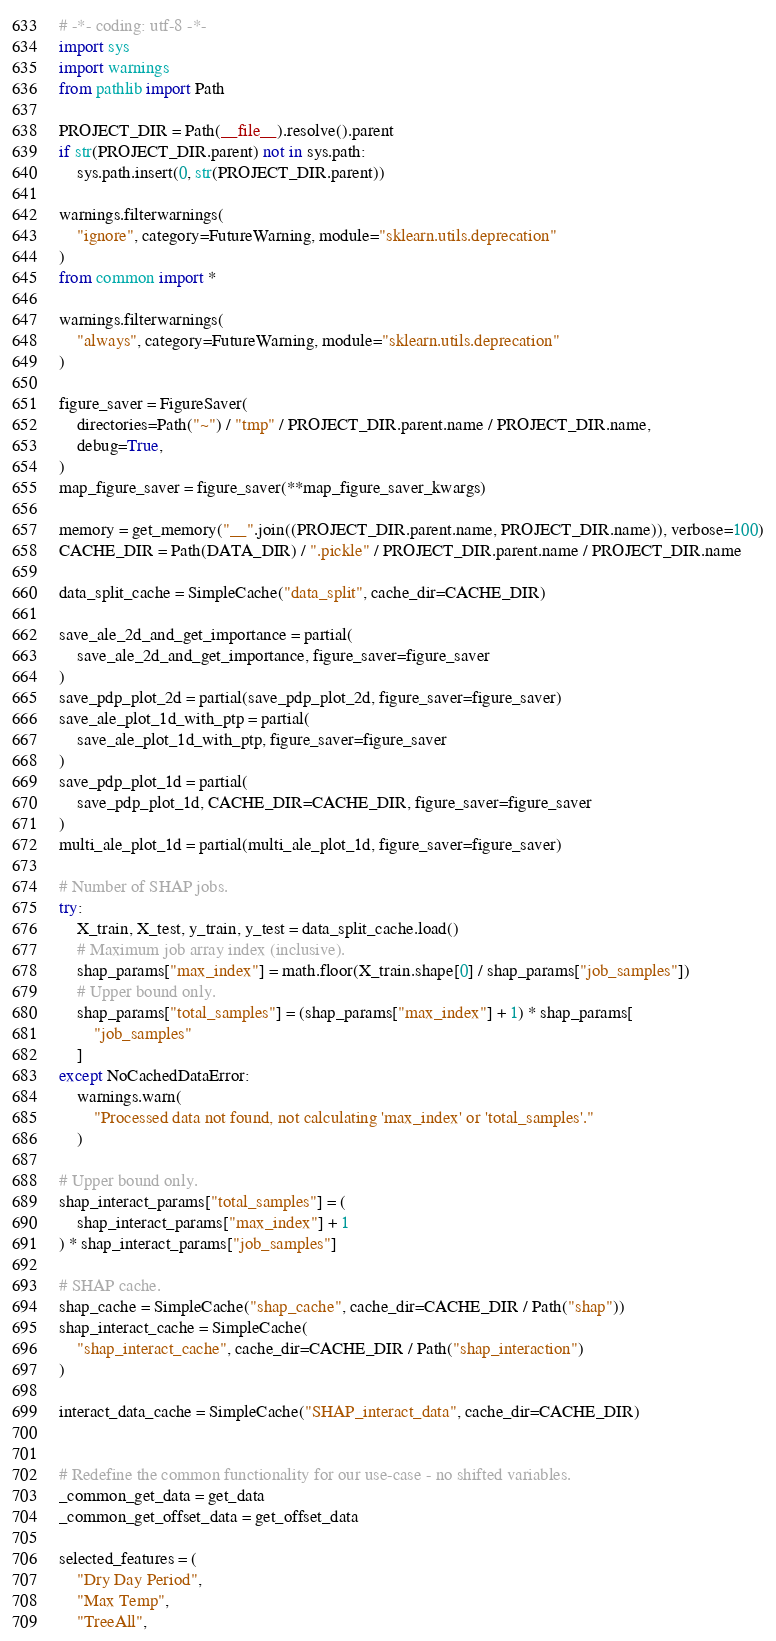<code> <loc_0><loc_0><loc_500><loc_500><_Python_># -*- coding: utf-8 -*-
import sys
import warnings
from pathlib import Path

PROJECT_DIR = Path(__file__).resolve().parent
if str(PROJECT_DIR.parent) not in sys.path:
    sys.path.insert(0, str(PROJECT_DIR.parent))

warnings.filterwarnings(
    "ignore", category=FutureWarning, module="sklearn.utils.deprecation"
)
from common import *

warnings.filterwarnings(
    "always", category=FutureWarning, module="sklearn.utils.deprecation"
)

figure_saver = FigureSaver(
    directories=Path("~") / "tmp" / PROJECT_DIR.parent.name / PROJECT_DIR.name,
    debug=True,
)
map_figure_saver = figure_saver(**map_figure_saver_kwargs)

memory = get_memory("__".join((PROJECT_DIR.parent.name, PROJECT_DIR.name)), verbose=100)
CACHE_DIR = Path(DATA_DIR) / ".pickle" / PROJECT_DIR.parent.name / PROJECT_DIR.name

data_split_cache = SimpleCache("data_split", cache_dir=CACHE_DIR)

save_ale_2d_and_get_importance = partial(
    save_ale_2d_and_get_importance, figure_saver=figure_saver
)
save_pdp_plot_2d = partial(save_pdp_plot_2d, figure_saver=figure_saver)
save_ale_plot_1d_with_ptp = partial(
    save_ale_plot_1d_with_ptp, figure_saver=figure_saver
)
save_pdp_plot_1d = partial(
    save_pdp_plot_1d, CACHE_DIR=CACHE_DIR, figure_saver=figure_saver
)
multi_ale_plot_1d = partial(multi_ale_plot_1d, figure_saver=figure_saver)

# Number of SHAP jobs.
try:
    X_train, X_test, y_train, y_test = data_split_cache.load()
    # Maximum job array index (inclusive).
    shap_params["max_index"] = math.floor(X_train.shape[0] / shap_params["job_samples"])
    # Upper bound only.
    shap_params["total_samples"] = (shap_params["max_index"] + 1) * shap_params[
        "job_samples"
    ]
except NoCachedDataError:
    warnings.warn(
        "Processed data not found, not calculating 'max_index' or 'total_samples'."
    )

# Upper bound only.
shap_interact_params["total_samples"] = (
    shap_interact_params["max_index"] + 1
) * shap_interact_params["job_samples"]

# SHAP cache.
shap_cache = SimpleCache("shap_cache", cache_dir=CACHE_DIR / Path("shap"))
shap_interact_cache = SimpleCache(
    "shap_interact_cache", cache_dir=CACHE_DIR / Path("shap_interaction")
)

interact_data_cache = SimpleCache("SHAP_interact_data", cache_dir=CACHE_DIR)


# Redefine the common functionality for our use-case - no shifted variables.
_common_get_data = get_data
_common_get_offset_data = get_offset_data

selected_features = (
    "Dry Day Period",
    "Max Temp",
    "TreeAll",</code> 